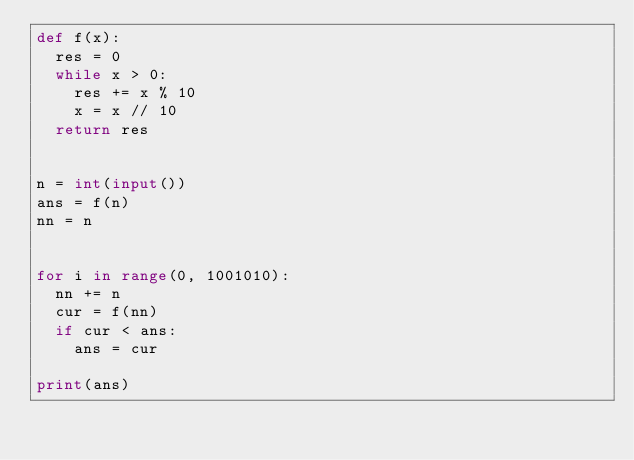<code> <loc_0><loc_0><loc_500><loc_500><_Python_>def f(x):
	res = 0
	while x > 0:
		res += x % 10
		x = x // 10
	return res


n = int(input())
ans = f(n)
nn = n


for i in range(0, 1001010):
	nn += n
	cur = f(nn)
	if cur < ans:
		ans = cur

print(ans)</code> 